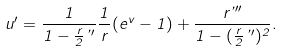<formula> <loc_0><loc_0><loc_500><loc_500>u ^ { \prime } = \frac { 1 } { 1 - \frac { r } { 2 } \varphi ^ { \prime } } \frac { 1 } { r } ( e ^ { v } - 1 ) + \frac { r \varphi ^ { \prime \prime } } { 1 - ( \frac { r } { 2 } \varphi ^ { \prime } ) ^ { 2 } } .</formula> 